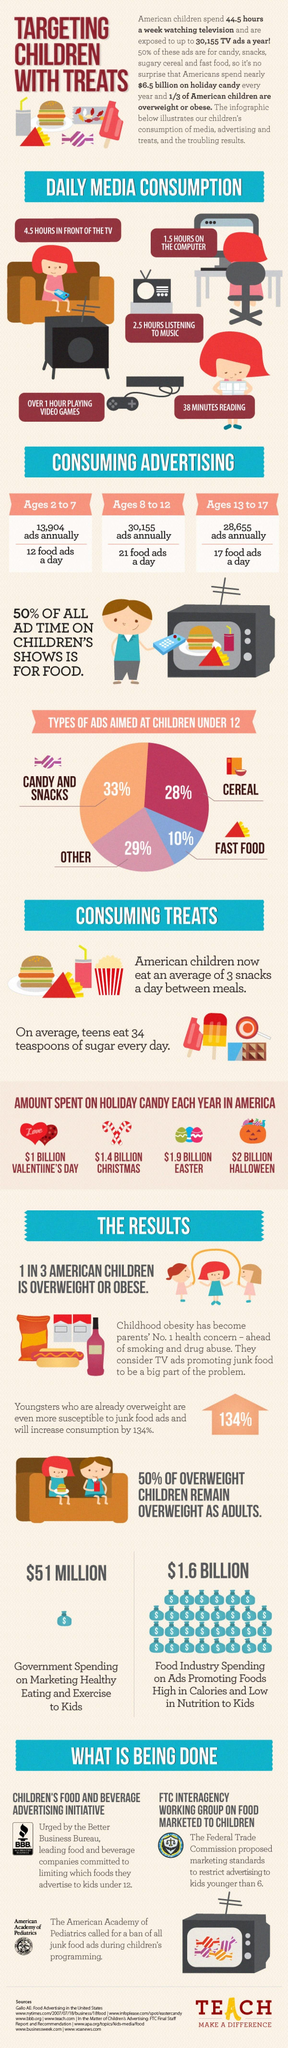List a handful of essential elements in this visual. The food industry spends 1.6 billion dollars on advertising. The majority of spending on candy occurs during Easter, as opposed to Christmas. Valentine's Day is a time when billions of dollars are spent on candy. In fact, it is estimated that over one billion dollars is spent specifically on candy during this holiday. Each year, a total of 28,655 advertisements are targeted towards children, with a specific focus on those within the age range of 13 to 17. The government spent $51 million on promoting healthy eating to children. 